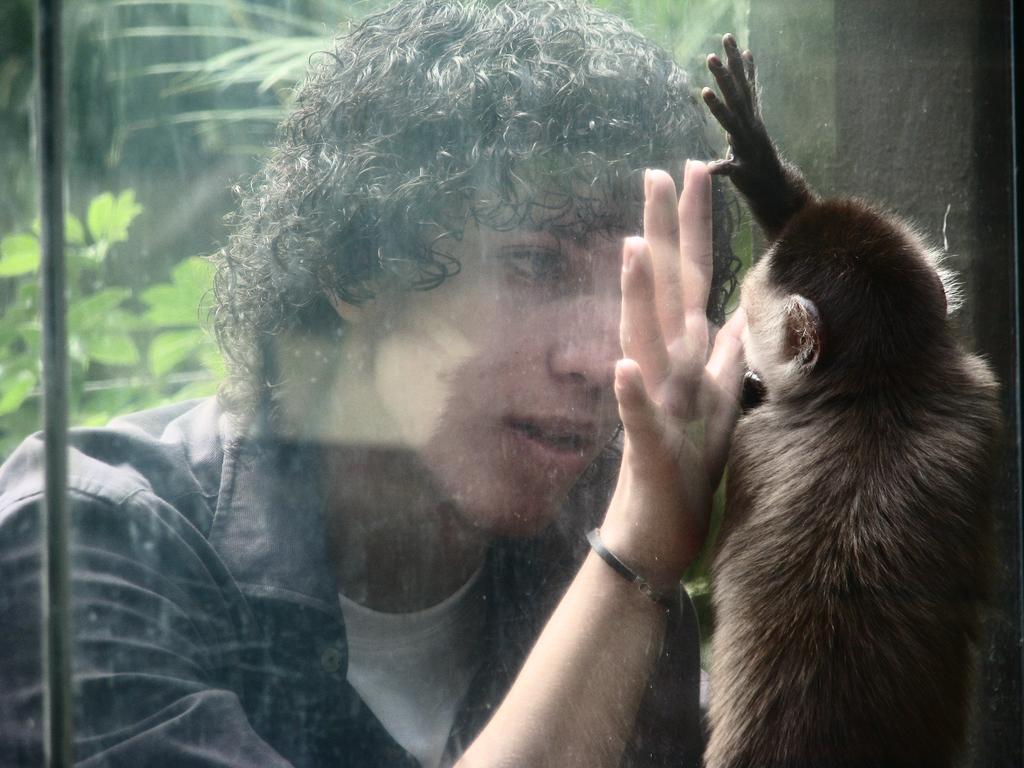What type of animal is in the image? There is a monkey in the image. Who or what else is present in the image? There is a person in the image. What can be seen in the background of the image? There are trees in the background of the image. What type of snails can be seen interacting with the monkey in the image? There are no snails present in the image, and therefore no such interaction can be observed. 